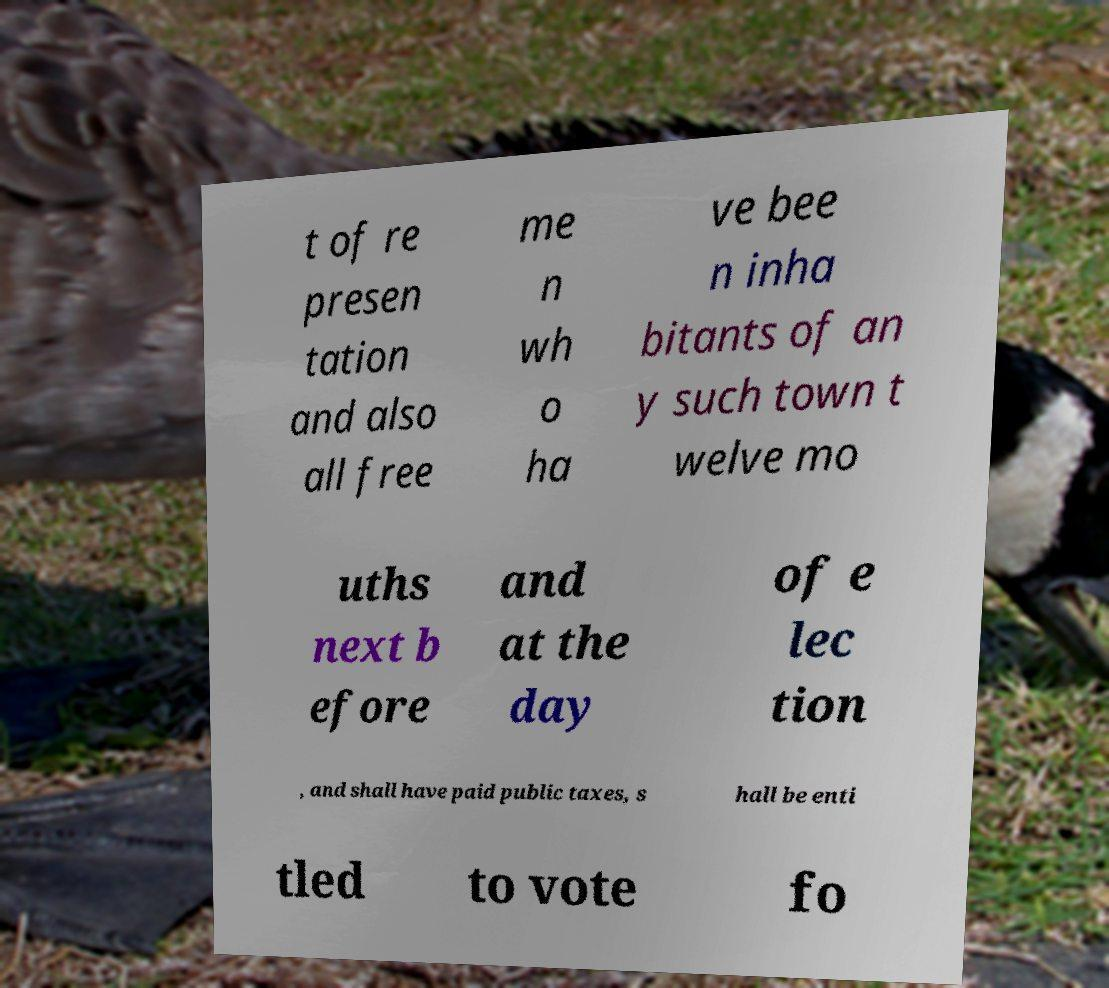For documentation purposes, I need the text within this image transcribed. Could you provide that? t of re presen tation and also all free me n wh o ha ve bee n inha bitants of an y such town t welve mo uths next b efore and at the day of e lec tion , and shall have paid public taxes, s hall be enti tled to vote fo 